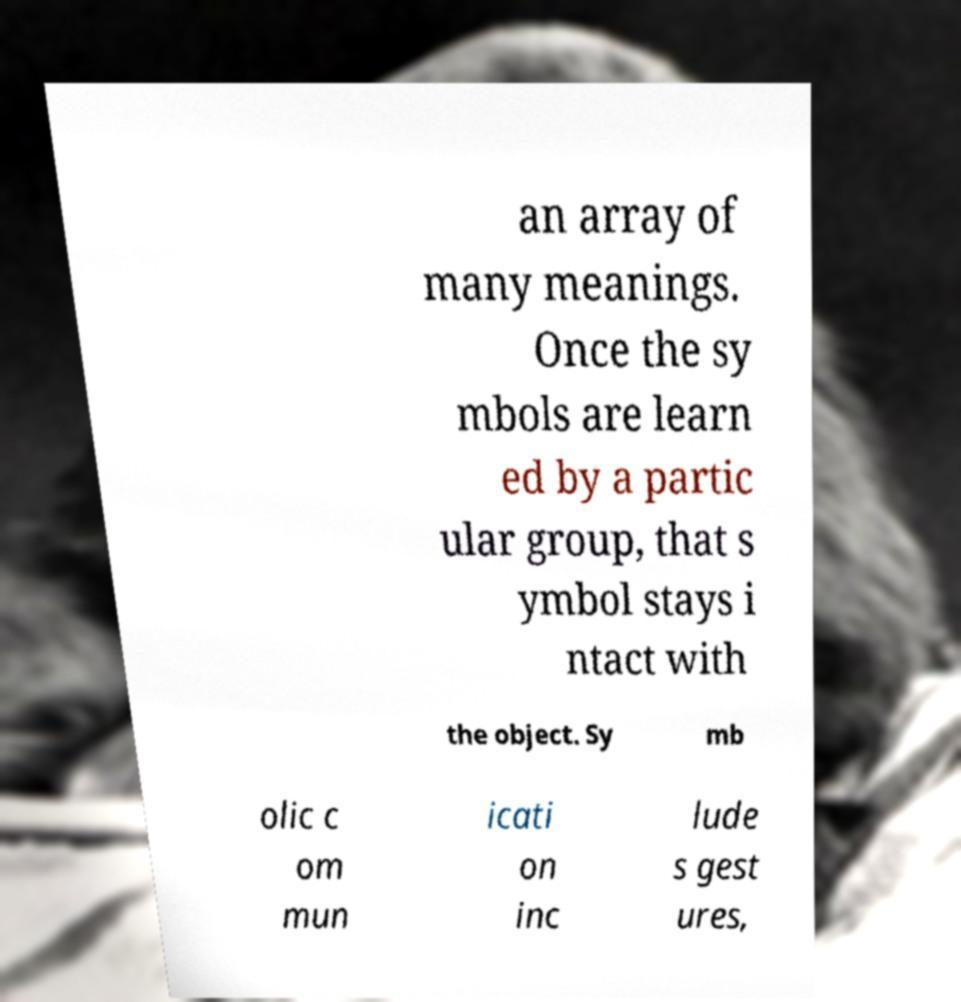Can you read and provide the text displayed in the image?This photo seems to have some interesting text. Can you extract and type it out for me? an array of many meanings. Once the sy mbols are learn ed by a partic ular group, that s ymbol stays i ntact with the object. Sy mb olic c om mun icati on inc lude s gest ures, 